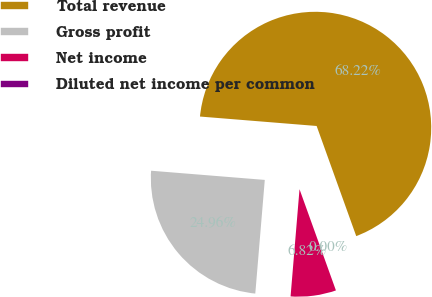<chart> <loc_0><loc_0><loc_500><loc_500><pie_chart><fcel>Total revenue<fcel>Gross profit<fcel>Net income<fcel>Diluted net income per common<nl><fcel>68.22%<fcel>24.96%<fcel>6.82%<fcel>0.0%<nl></chart> 